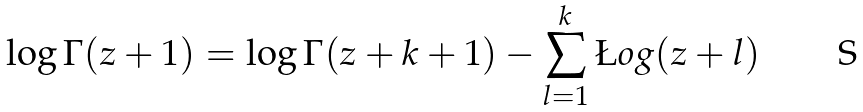Convert formula to latex. <formula><loc_0><loc_0><loc_500><loc_500>\log \Gamma ( z + 1 ) = \log \Gamma ( z + k + 1 ) - \sum _ { l = 1 } ^ { k } \L o g ( z + l )</formula> 